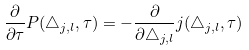<formula> <loc_0><loc_0><loc_500><loc_500>\frac { \partial } { \partial \tau } P ( \bigtriangleup _ { j , l } , \tau ) = - \frac { \partial } { \partial \bigtriangleup _ { j , l } } j ( \bigtriangleup _ { j , l } , \tau )</formula> 